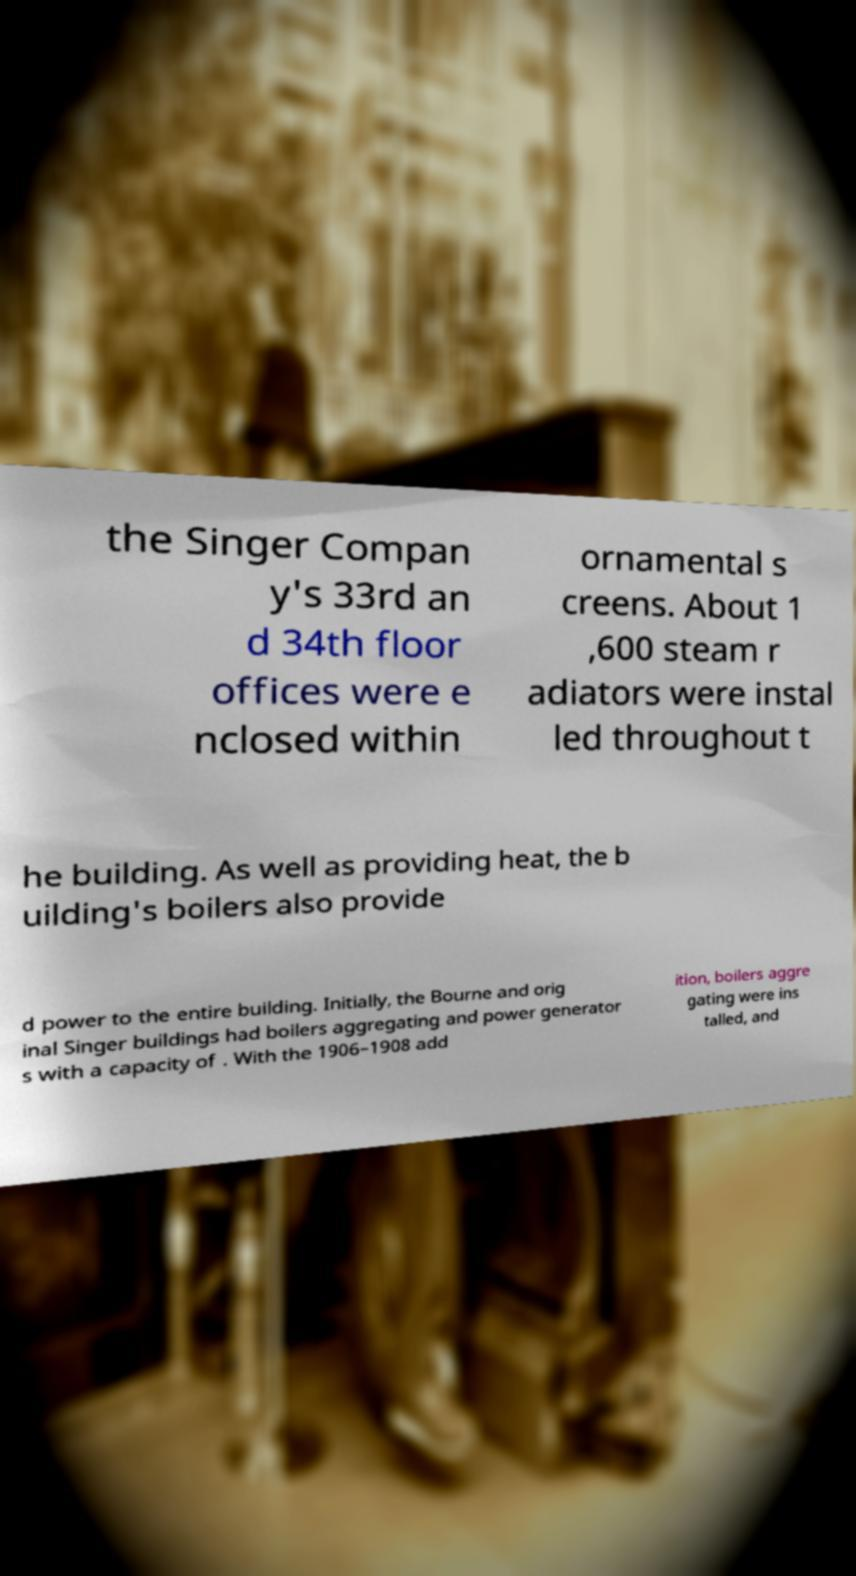Could you extract and type out the text from this image? the Singer Compan y's 33rd an d 34th floor offices were e nclosed within ornamental s creens. About 1 ,600 steam r adiators were instal led throughout t he building. As well as providing heat, the b uilding's boilers also provide d power to the entire building. Initially, the Bourne and orig inal Singer buildings had boilers aggregating and power generator s with a capacity of . With the 1906–1908 add ition, boilers aggre gating were ins talled, and 